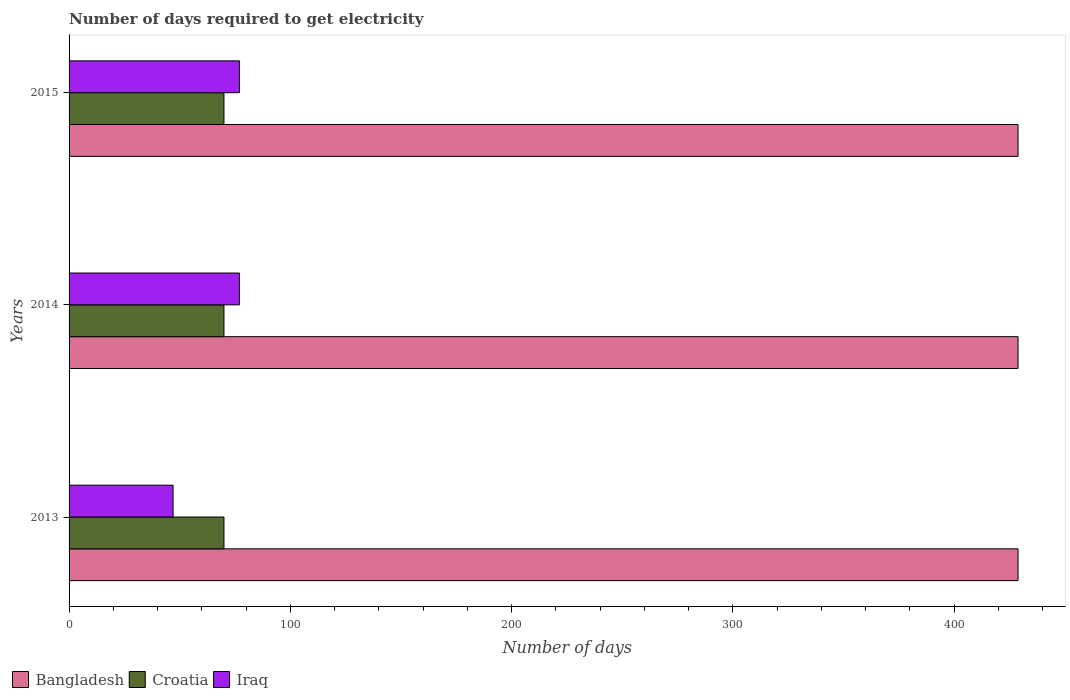How many different coloured bars are there?
Ensure brevity in your answer.  3. How many groups of bars are there?
Provide a succinct answer. 3. Are the number of bars per tick equal to the number of legend labels?
Offer a terse response. Yes. Are the number of bars on each tick of the Y-axis equal?
Provide a short and direct response. Yes. How many bars are there on the 1st tick from the bottom?
Your answer should be compact. 3. In how many cases, is the number of bars for a given year not equal to the number of legend labels?
Provide a succinct answer. 0. What is the number of days required to get electricity in in Bangladesh in 2015?
Your answer should be compact. 428.9. Across all years, what is the maximum number of days required to get electricity in in Iraq?
Give a very brief answer. 77. Across all years, what is the minimum number of days required to get electricity in in Croatia?
Provide a succinct answer. 70. In which year was the number of days required to get electricity in in Croatia maximum?
Your answer should be compact. 2013. What is the total number of days required to get electricity in in Iraq in the graph?
Give a very brief answer. 201. What is the difference between the number of days required to get electricity in in Bangladesh in 2013 and the number of days required to get electricity in in Croatia in 2015?
Ensure brevity in your answer.  358.9. What is the average number of days required to get electricity in in Croatia per year?
Keep it short and to the point. 70. In the year 2015, what is the difference between the number of days required to get electricity in in Iraq and number of days required to get electricity in in Bangladesh?
Keep it short and to the point. -351.9. In how many years, is the number of days required to get electricity in in Croatia greater than 320 days?
Offer a terse response. 0. What is the ratio of the number of days required to get electricity in in Iraq in 2013 to that in 2014?
Your answer should be very brief. 0.61. Is the number of days required to get electricity in in Croatia in 2013 less than that in 2015?
Ensure brevity in your answer.  No. Is the sum of the number of days required to get electricity in in Iraq in 2014 and 2015 greater than the maximum number of days required to get electricity in in Bangladesh across all years?
Offer a terse response. No. What does the 2nd bar from the top in 2013 represents?
Make the answer very short. Croatia. Is it the case that in every year, the sum of the number of days required to get electricity in in Iraq and number of days required to get electricity in in Bangladesh is greater than the number of days required to get electricity in in Croatia?
Give a very brief answer. Yes. Are all the bars in the graph horizontal?
Ensure brevity in your answer.  Yes. How many years are there in the graph?
Keep it short and to the point. 3. What is the difference between two consecutive major ticks on the X-axis?
Your answer should be compact. 100. Are the values on the major ticks of X-axis written in scientific E-notation?
Offer a terse response. No. Does the graph contain any zero values?
Provide a short and direct response. No. How are the legend labels stacked?
Keep it short and to the point. Horizontal. What is the title of the graph?
Offer a terse response. Number of days required to get electricity. What is the label or title of the X-axis?
Offer a terse response. Number of days. What is the Number of days of Bangladesh in 2013?
Provide a succinct answer. 428.9. What is the Number of days of Croatia in 2013?
Ensure brevity in your answer.  70. What is the Number of days in Iraq in 2013?
Provide a succinct answer. 47. What is the Number of days of Bangladesh in 2014?
Provide a succinct answer. 428.9. What is the Number of days in Iraq in 2014?
Make the answer very short. 77. What is the Number of days in Bangladesh in 2015?
Ensure brevity in your answer.  428.9. Across all years, what is the maximum Number of days of Bangladesh?
Provide a succinct answer. 428.9. Across all years, what is the maximum Number of days of Iraq?
Keep it short and to the point. 77. Across all years, what is the minimum Number of days of Bangladesh?
Keep it short and to the point. 428.9. What is the total Number of days of Bangladesh in the graph?
Your response must be concise. 1286.7. What is the total Number of days of Croatia in the graph?
Ensure brevity in your answer.  210. What is the total Number of days in Iraq in the graph?
Provide a short and direct response. 201. What is the difference between the Number of days in Bangladesh in 2013 and that in 2014?
Keep it short and to the point. 0. What is the difference between the Number of days in Iraq in 2014 and that in 2015?
Give a very brief answer. 0. What is the difference between the Number of days of Bangladesh in 2013 and the Number of days of Croatia in 2014?
Ensure brevity in your answer.  358.9. What is the difference between the Number of days of Bangladesh in 2013 and the Number of days of Iraq in 2014?
Offer a very short reply. 351.9. What is the difference between the Number of days in Croatia in 2013 and the Number of days in Iraq in 2014?
Offer a terse response. -7. What is the difference between the Number of days in Bangladesh in 2013 and the Number of days in Croatia in 2015?
Your response must be concise. 358.9. What is the difference between the Number of days of Bangladesh in 2013 and the Number of days of Iraq in 2015?
Give a very brief answer. 351.9. What is the difference between the Number of days in Bangladesh in 2014 and the Number of days in Croatia in 2015?
Offer a very short reply. 358.9. What is the difference between the Number of days of Bangladesh in 2014 and the Number of days of Iraq in 2015?
Provide a succinct answer. 351.9. What is the difference between the Number of days of Croatia in 2014 and the Number of days of Iraq in 2015?
Your answer should be compact. -7. What is the average Number of days of Bangladesh per year?
Give a very brief answer. 428.9. What is the average Number of days of Croatia per year?
Provide a short and direct response. 70. In the year 2013, what is the difference between the Number of days of Bangladesh and Number of days of Croatia?
Make the answer very short. 358.9. In the year 2013, what is the difference between the Number of days of Bangladesh and Number of days of Iraq?
Offer a very short reply. 381.9. In the year 2014, what is the difference between the Number of days of Bangladesh and Number of days of Croatia?
Ensure brevity in your answer.  358.9. In the year 2014, what is the difference between the Number of days in Bangladesh and Number of days in Iraq?
Keep it short and to the point. 351.9. In the year 2014, what is the difference between the Number of days in Croatia and Number of days in Iraq?
Make the answer very short. -7. In the year 2015, what is the difference between the Number of days in Bangladesh and Number of days in Croatia?
Offer a very short reply. 358.9. In the year 2015, what is the difference between the Number of days of Bangladesh and Number of days of Iraq?
Give a very brief answer. 351.9. What is the ratio of the Number of days in Iraq in 2013 to that in 2014?
Keep it short and to the point. 0.61. What is the ratio of the Number of days in Croatia in 2013 to that in 2015?
Provide a succinct answer. 1. What is the ratio of the Number of days in Iraq in 2013 to that in 2015?
Make the answer very short. 0.61. What is the difference between the highest and the second highest Number of days of Bangladesh?
Make the answer very short. 0. What is the difference between the highest and the lowest Number of days in Bangladesh?
Make the answer very short. 0. What is the difference between the highest and the lowest Number of days of Croatia?
Make the answer very short. 0. What is the difference between the highest and the lowest Number of days in Iraq?
Your response must be concise. 30. 